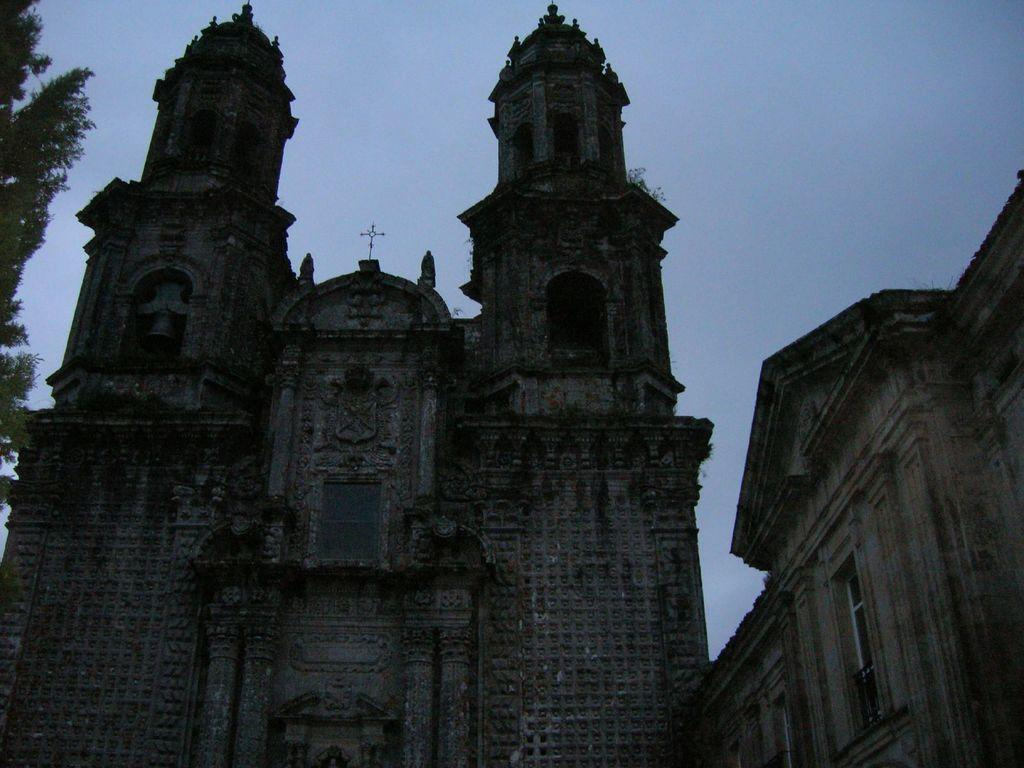What type of structure is depicted in the image? There is an old architecture building in the image. What can be seen on the left side of the building? There are trees on the left side of the building. What is visible behind the building? The sky is visible behind the building. Can you see a drum being played in the image? There is no drum or anyone playing a drum present in the image. 